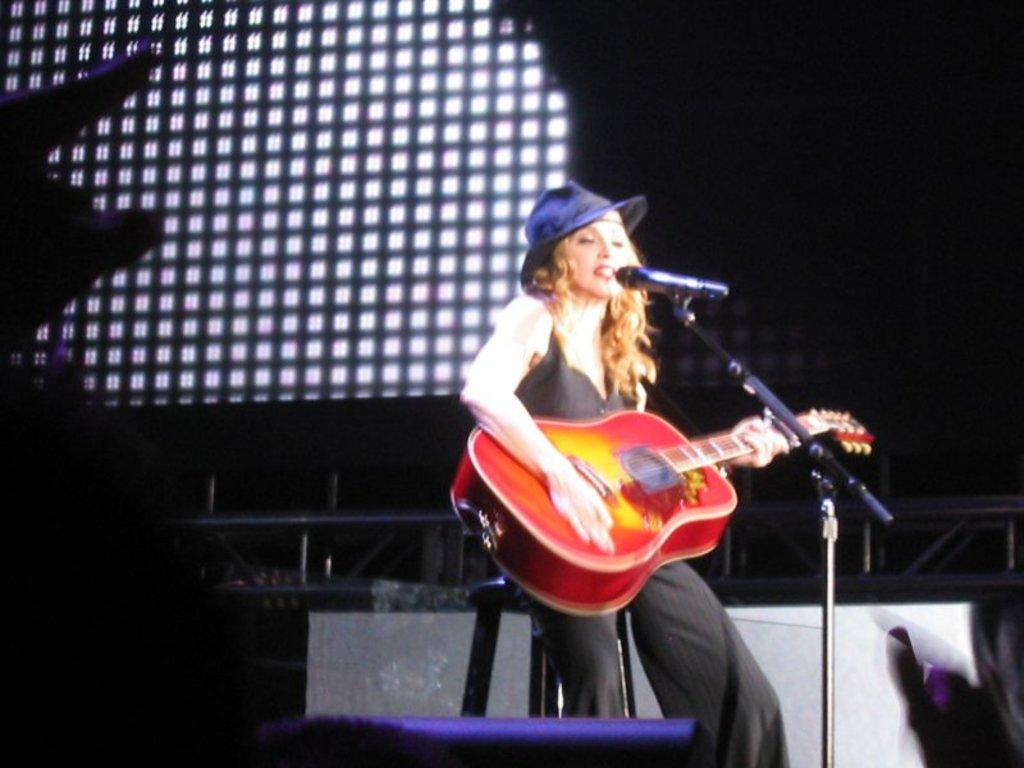What is the overall color scheme of the image? The background of the image is dark. Can you describe the woman in the image? There is a woman in the image, and she is wearing a blue hat. What is the woman doing in the image? The woman is sitting in front of a microphone and singing while playing a guitar. What type of cloth is being used to make the selection in the image? There is no selection or cloth present in the image; it features a woman singing and playing a guitar. Can you tell me how the chalk is being used in the image? There is no chalk present in the image. 